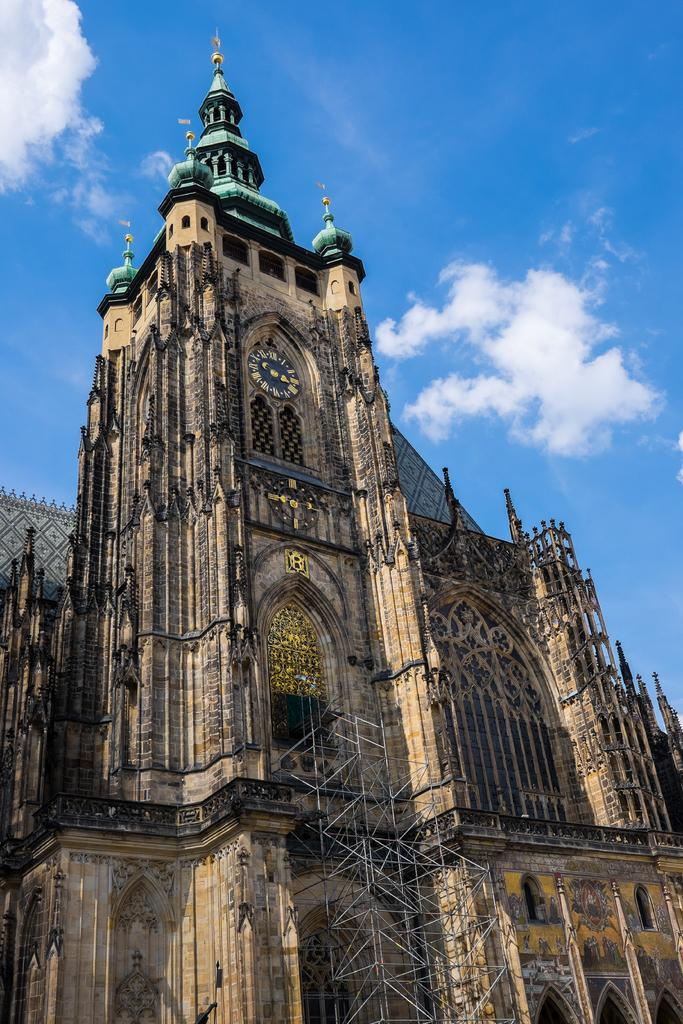What is the main subject in the image? There is a building in the image. What type of stove is used by the cook during the day in the image? There is no cook or stove present in the image; it only features a building. 